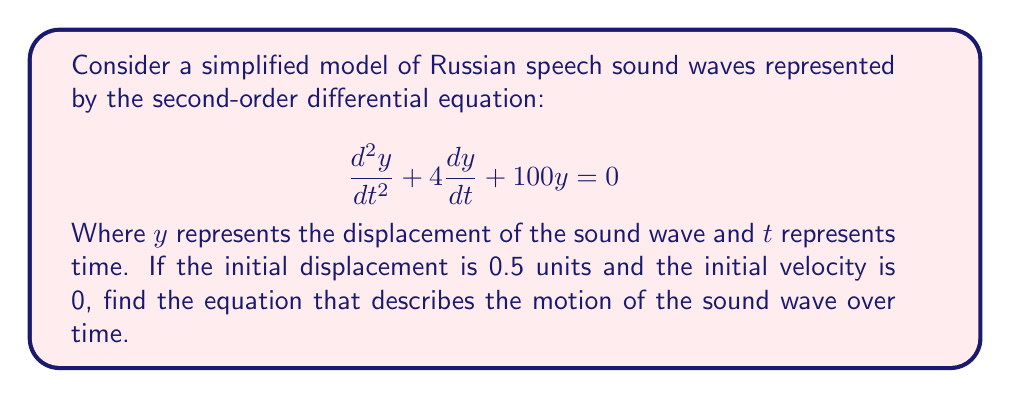Can you solve this math problem? To solve this problem, we'll follow these steps:

1) The given equation is in the form of a second-order linear differential equation:
   $$\frac{d^2y}{dt^2} + 2\zeta\omega_n\frac{dy}{dt} + \omega_n^2y = 0$$
   Where $\zeta$ is the damping ratio and $\omega_n$ is the natural frequency.

2) From our equation, we can identify:
   $2\zeta\omega_n = 4$ and $\omega_n^2 = 100$

3) Solving for $\omega_n$:
   $\omega_n = \sqrt{100} = 10$ rad/s

4) Solving for $\zeta$:
   $\zeta = \frac{4}{2\omega_n} = \frac{4}{20} = 0.2$

5) Since $0 < \zeta < 1$, this is an underdamped system. The general solution for an underdamped system is:
   $$y(t) = e^{-\zeta\omega_n t}(A\cos(\omega_d t) + B\sin(\omega_d t))$$
   Where $\omega_d = \omega_n\sqrt{1-\zeta^2}$ is the damped natural frequency.

6) Calculate $\omega_d$:
   $\omega_d = 10\sqrt{1-0.2^2} = 9.798$ rad/s

7) We're given two initial conditions:
   $y(0) = 0.5$ (initial displacement)
   $y'(0) = 0$ (initial velocity)

8) Using the initial displacement condition:
   $0.5 = A$

9) Taking the derivative of the general solution and applying the initial velocity condition:
   $y'(t) = -2e^{-2t}(0.5\cos(9.798t)) + 9.798e^{-2t}B\cos(9.798t)$
   $0 = -1 + 9.798B$
   $B = \frac{1}{9.798} = 0.102$

10) Therefore, the final solution is:
    $$y(t) = e^{-2t}(0.5\cos(9.798t) + 0.102\sin(9.798t))$$
Answer: $$y(t) = e^{-2t}(0.5\cos(9.798t) + 0.102\sin(9.798t))$$ 